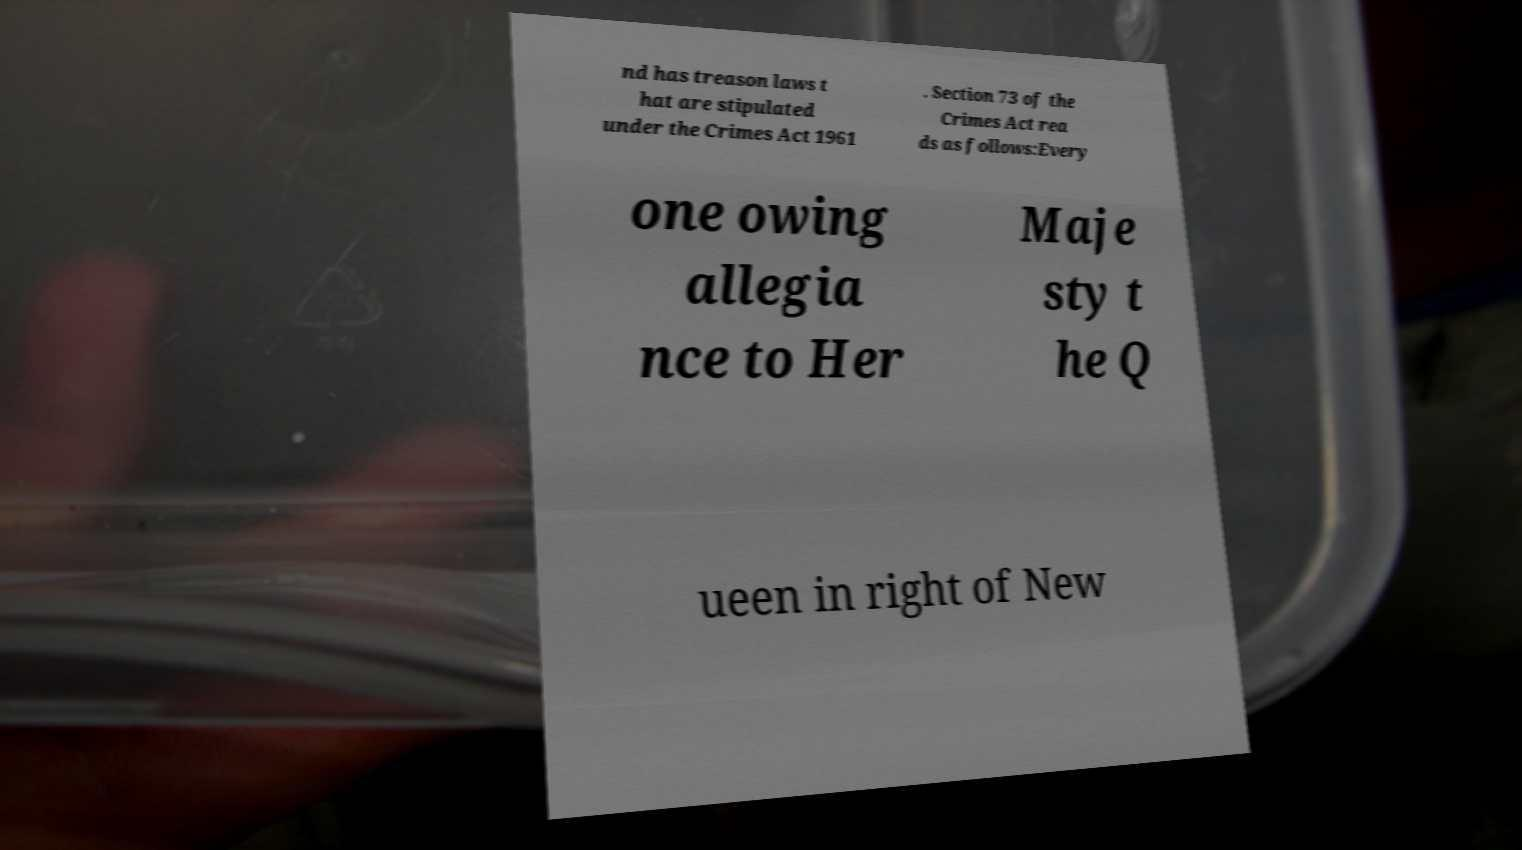Could you extract and type out the text from this image? nd has treason laws t hat are stipulated under the Crimes Act 1961 . Section 73 of the Crimes Act rea ds as follows:Every one owing allegia nce to Her Maje sty t he Q ueen in right of New 